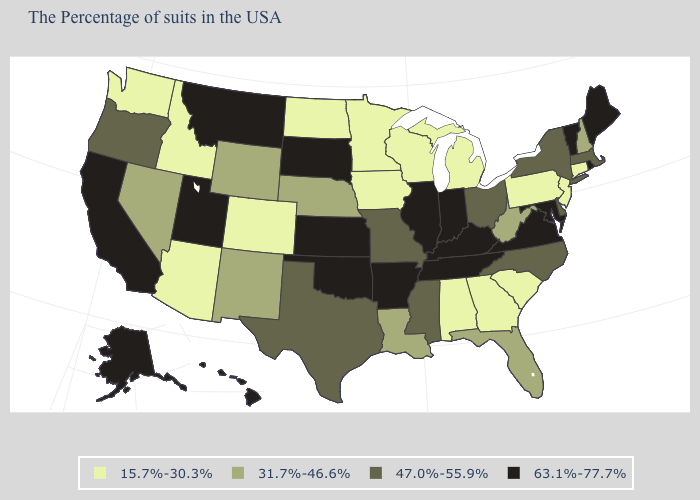What is the lowest value in states that border Michigan?
Short answer required. 15.7%-30.3%. Does the first symbol in the legend represent the smallest category?
Write a very short answer. Yes. Among the states that border Rhode Island , which have the highest value?
Answer briefly. Massachusetts. What is the value of Mississippi?
Quick response, please. 47.0%-55.9%. Name the states that have a value in the range 15.7%-30.3%?
Write a very short answer. Connecticut, New Jersey, Pennsylvania, South Carolina, Georgia, Michigan, Alabama, Wisconsin, Minnesota, Iowa, North Dakota, Colorado, Arizona, Idaho, Washington. What is the value of Massachusetts?
Concise answer only. 47.0%-55.9%. Does Indiana have a higher value than California?
Concise answer only. No. Does Louisiana have the same value as Massachusetts?
Write a very short answer. No. Name the states that have a value in the range 15.7%-30.3%?
Keep it brief. Connecticut, New Jersey, Pennsylvania, South Carolina, Georgia, Michigan, Alabama, Wisconsin, Minnesota, Iowa, North Dakota, Colorado, Arizona, Idaho, Washington. What is the value of Iowa?
Concise answer only. 15.7%-30.3%. What is the lowest value in the MidWest?
Short answer required. 15.7%-30.3%. Name the states that have a value in the range 63.1%-77.7%?
Be succinct. Maine, Rhode Island, Vermont, Maryland, Virginia, Kentucky, Indiana, Tennessee, Illinois, Arkansas, Kansas, Oklahoma, South Dakota, Utah, Montana, California, Alaska, Hawaii. Does Florida have a higher value than Georgia?
Short answer required. Yes. What is the lowest value in states that border Minnesota?
Concise answer only. 15.7%-30.3%. Which states hav the highest value in the MidWest?
Answer briefly. Indiana, Illinois, Kansas, South Dakota. 